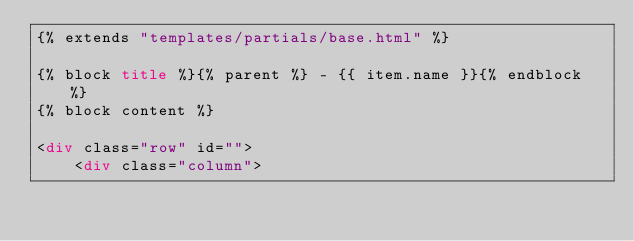Convert code to text. <code><loc_0><loc_0><loc_500><loc_500><_HTML_>{% extends "templates/partials/base.html" %}

{% block title %}{% parent %} - {{ item.name }}{% endblock %}
{% block content %}

<div class="row" id="">
	<div class="column"></code> 